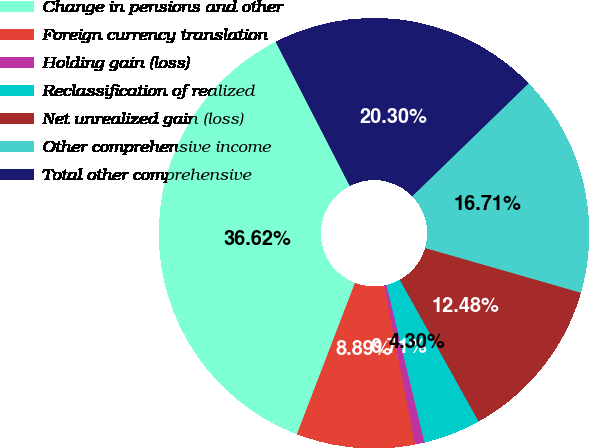Convert chart to OTSL. <chart><loc_0><loc_0><loc_500><loc_500><pie_chart><fcel>Change in pensions and other<fcel>Foreign currency translation<fcel>Holding gain (loss)<fcel>Reclassification of realized<fcel>Net unrealized gain (loss)<fcel>Other comprehensive income<fcel>Total other comprehensive<nl><fcel>36.62%<fcel>8.89%<fcel>0.71%<fcel>4.3%<fcel>12.48%<fcel>16.71%<fcel>20.3%<nl></chart> 